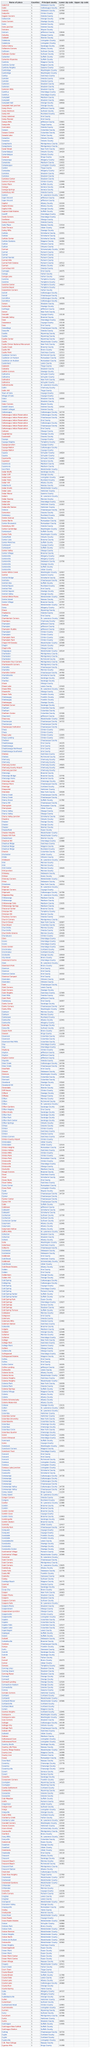Specify some key components in this picture. In Greene County, there are ten places. Cooper place has the lowest and lower zip code among all places. There are 10 total places in Greene County. The county listed above Cairo Junction is Calciana. Callicoon and Callicoon Center are located in Sullivan County. 